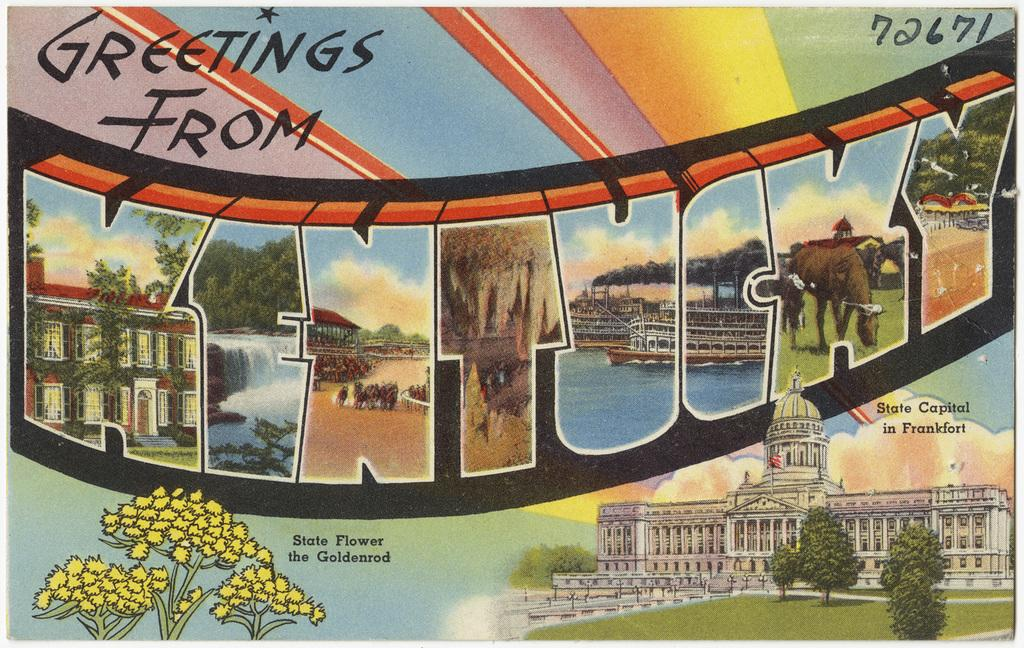<image>
Render a clear and concise summary of the photo. Old time post card that says Greetings From Kentucky 